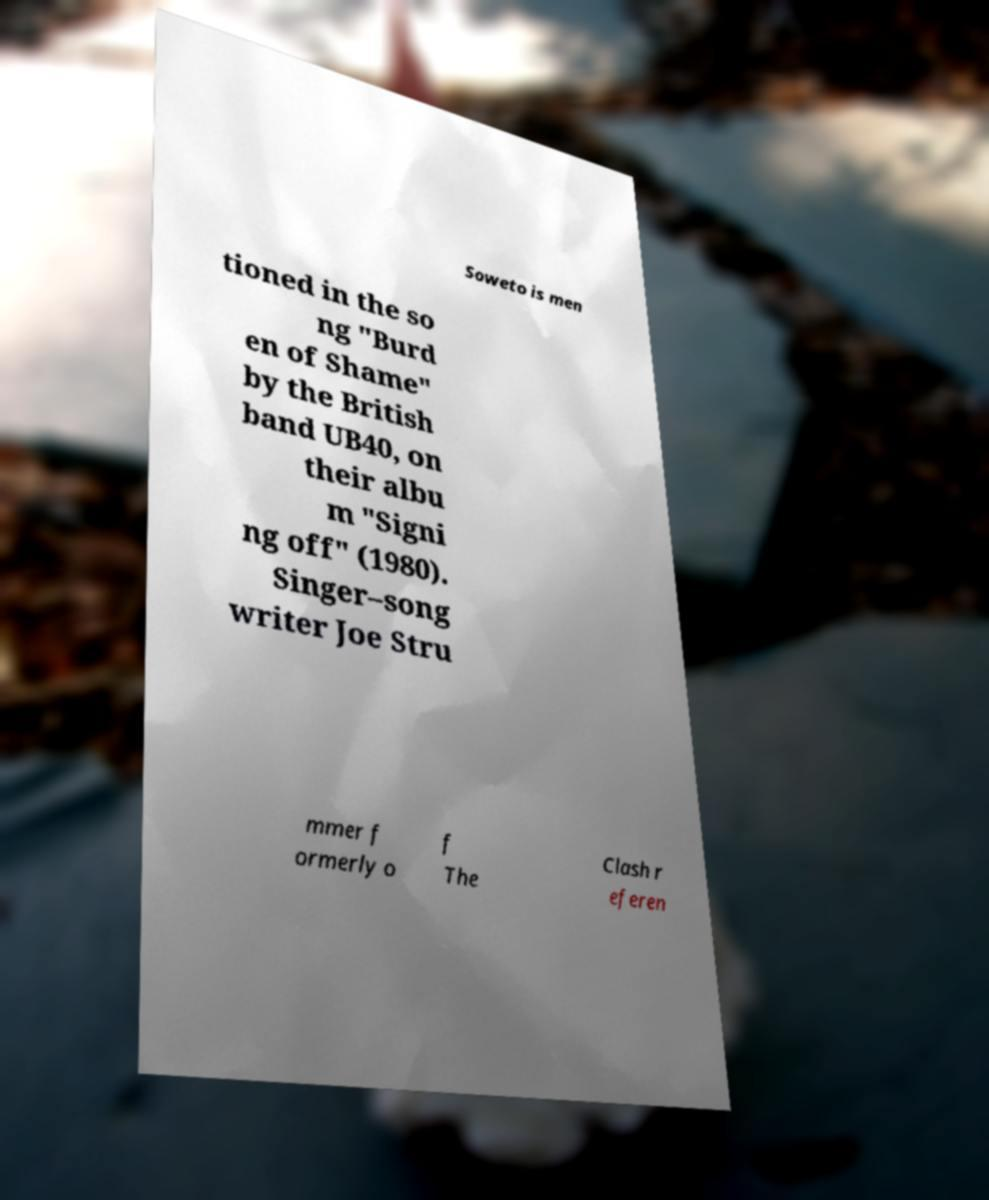Could you extract and type out the text from this image? Soweto is men tioned in the so ng "Burd en of Shame" by the British band UB40, on their albu m "Signi ng off" (1980). Singer–song writer Joe Stru mmer f ormerly o f The Clash r eferen 